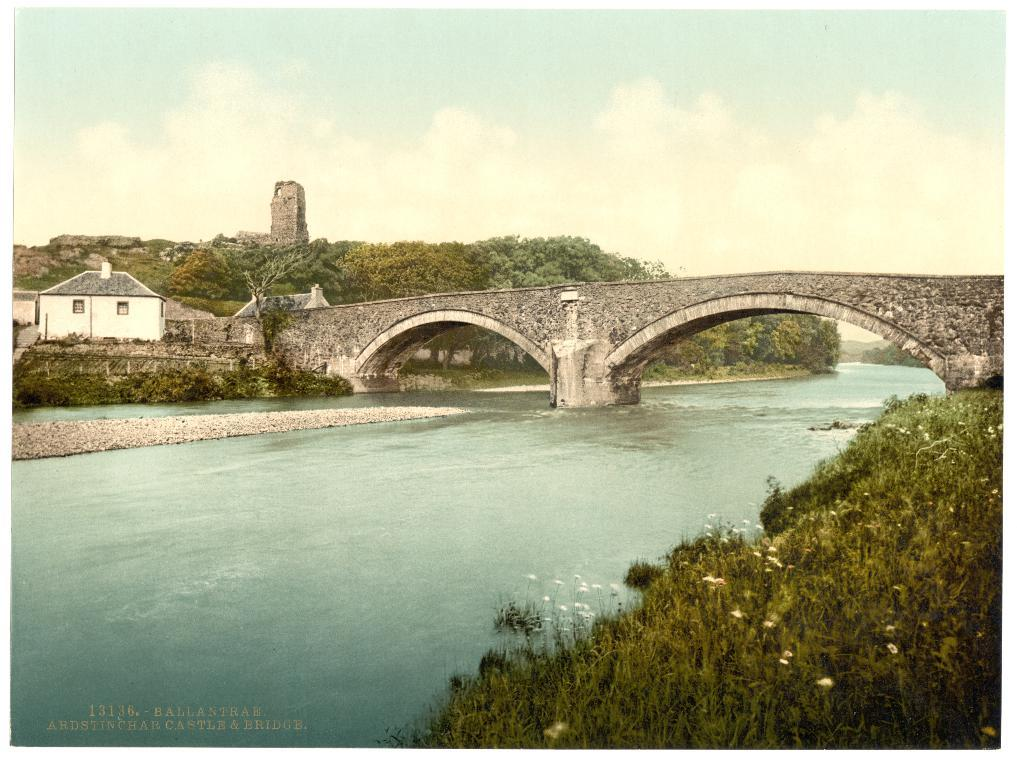What is the main structure visible in the image? There is a bridge in the image. What is the bridge positioned over? The bridge is over water. What type of vegetation can be seen in the image? There are trees, plants, and flowers in the image. What type of man-made structure is visible in the image? There is a building in the image. What is the material of the wall visible in the image? There is a stone wall in the image. What is visible in the sky in the image? There are clouds in the sky. What type of wax is being used to create the flowers in the image? There is no wax present in the image; the flowers are real or depicted as such. What type of underwear is visible on the bridge in the image? There is no underwear visible in the image; the focus is on the bridge, water, and surrounding environment. 